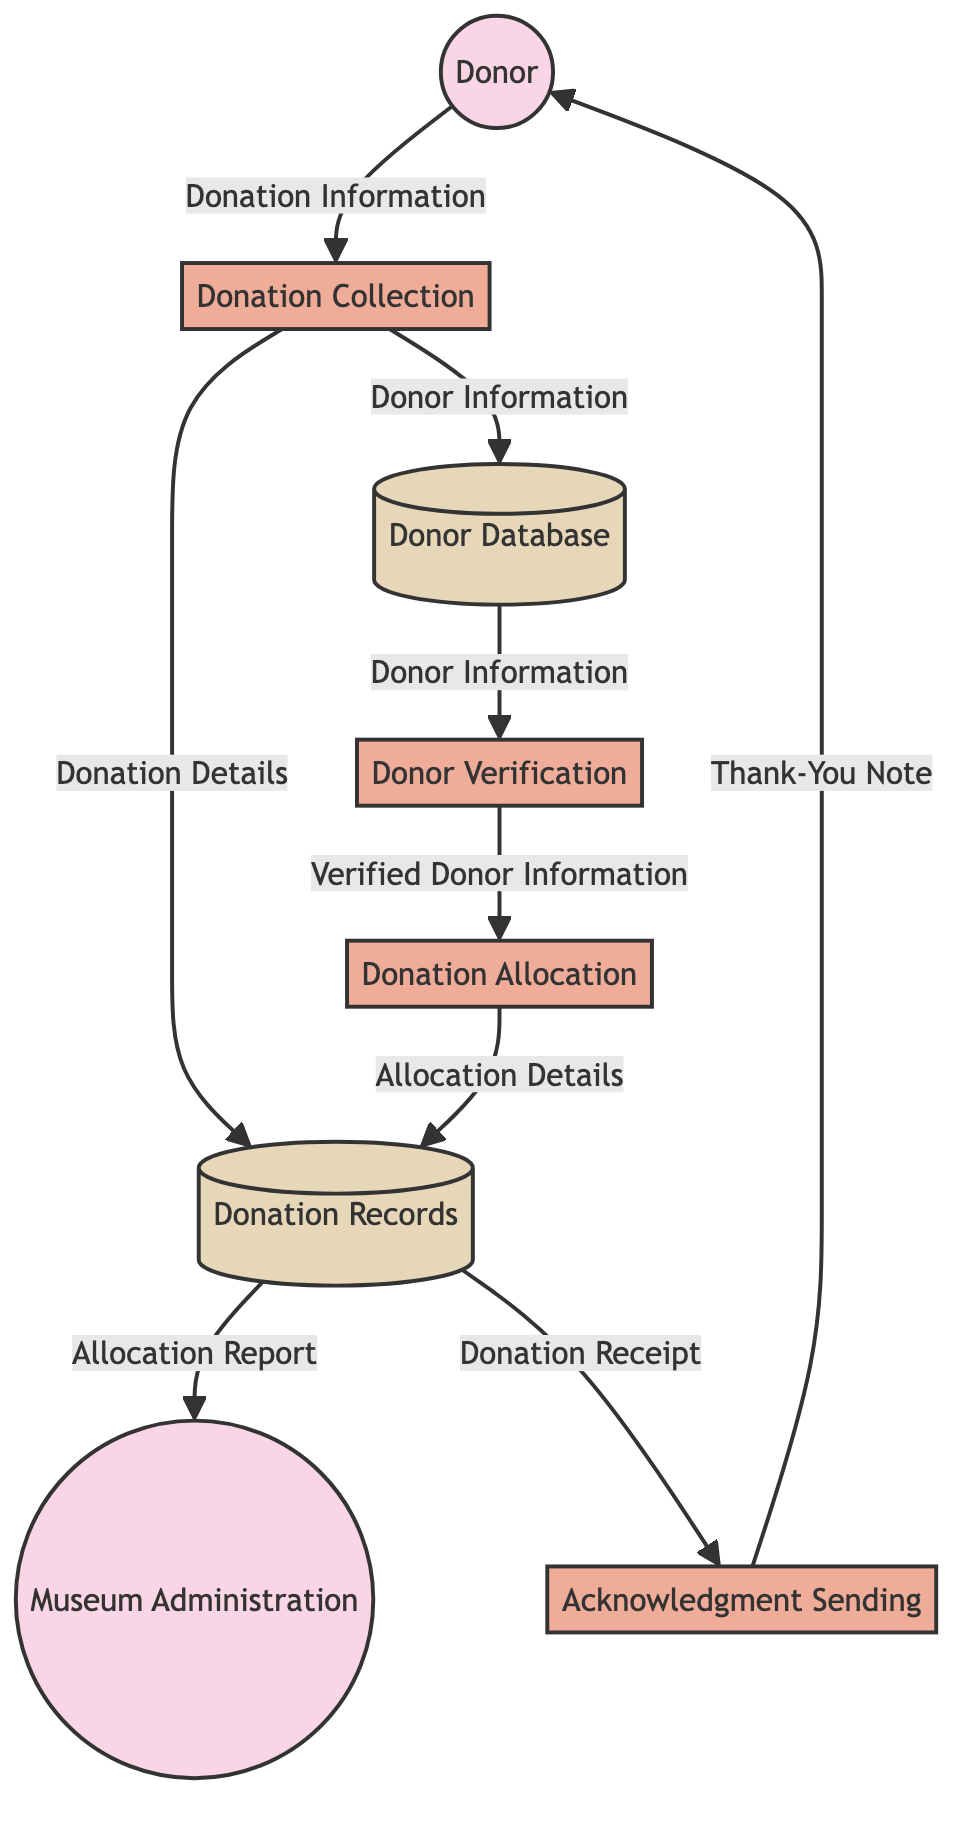What are the external entities in this diagram? The diagram lists two external entities: "Donor" and "Museum Administration." These reflect parties interacting with the donation management system.
Answer: Donor, Museum Administration How many data stores are identified? The diagram includes two data stores, "Donor Database" and "Donation Records," which store vital information related to donations and donors.
Answer: 2 What information flows from the Donation Collection to the Donation Records? The Donation Collection process transmits "Donation Details" to the Donation Records data store, capturing specifics of each donation event.
Answer: Donation Details Which process sends an acknowledgment to the donor? The "Acknowledgment Sending" process is responsible for sending the "Thank-You Note" to the donor, signifying their donation was received and valued.
Answer: Acknowledgment Sending What does the Donor Verification process receive as input? The Donor Verification process receives "Donor Information" from the Donor Database in order to verify the eligibility and details of the donor.
Answer: Donor Information How many processes are there in this diagram? The diagram outlines four processes: "Donation Collection," "Donor Verification," "Donation Allocation," and "Acknowledgment Sending," which define each step the donation management system follows.
Answer: 4 What type of report does the Museum Administration receive? The Museum Administration receives an "Allocation Report" from the Donation Records, detailing how donations have been distributed among various museum projects.
Answer: Allocation Report What is the main function of the Donation Allocation process? The Donation Allocation process is responsible for allocating received donations to different projects within the museum after verifying the donor information.
Answer: Allocation of donations How does the Donation Collection process interact with the Donor Database? The Donation Collection process records "Donor Information" into the Donor Database, ensuring that all relevant details about each donor are stored systematically.
Answer: Donor Information What type of note is sent to the donor after the acknowledgment process? After the acknowledgment process is completed, a "Thank-You Note" is sent to the donor as a gesture of appreciation for their contribution.
Answer: Thank-You Note 